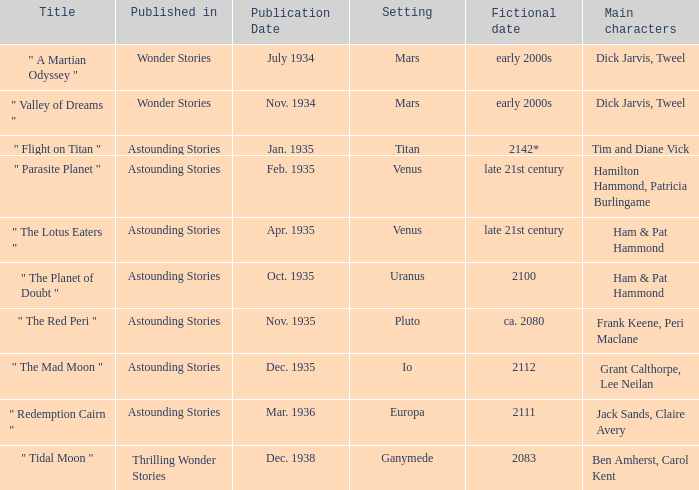Name what was published in july 1934 with a setting of mars Wonder Stories. 